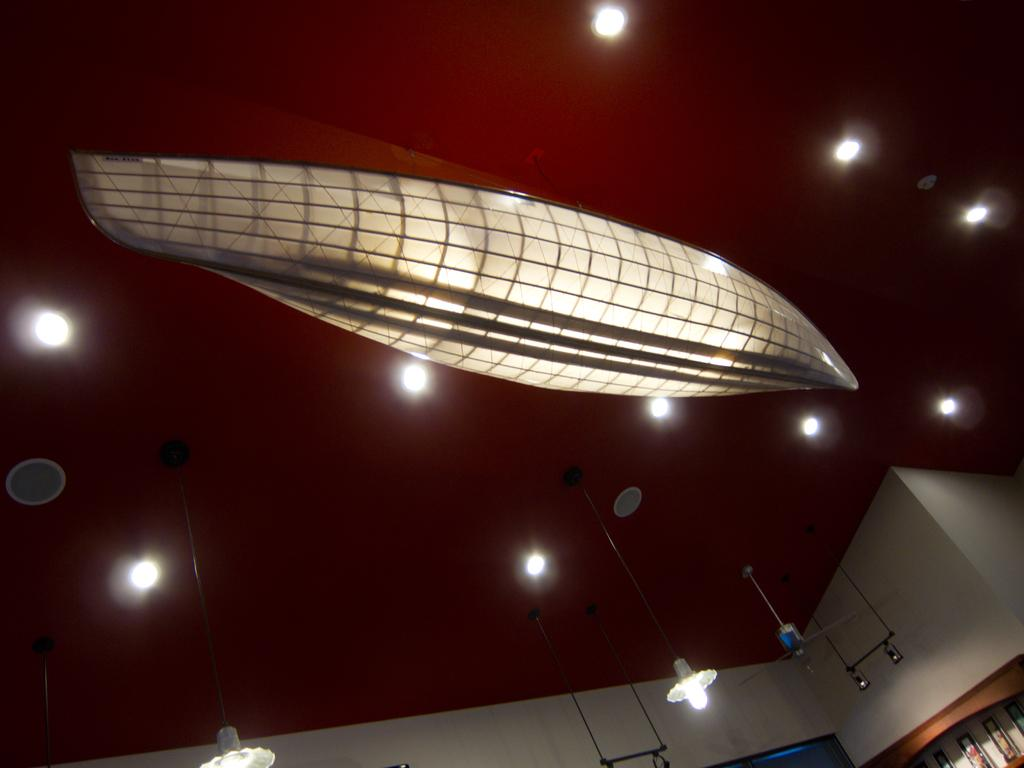What type of setting is depicted in the image? The image shows an inside view of a room. What can be seen on the wall in the foreground? There are photo frames on the wall in the foreground. What is visible in the background of the room? There is a group of lights in the background. What type of brush is used to clean the photo frames in the image? There is no brush visible in the image, and the photo frames do not appear to be dirty or in need of cleaning. 